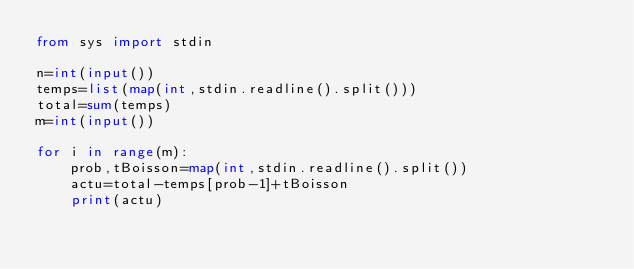<code> <loc_0><loc_0><loc_500><loc_500><_Python_>from sys import stdin

n=int(input())
temps=list(map(int,stdin.readline().split()))
total=sum(temps)
m=int(input())

for i in range(m):
    prob,tBoisson=map(int,stdin.readline().split())
    actu=total-temps[prob-1]+tBoisson
    print(actu)
</code> 